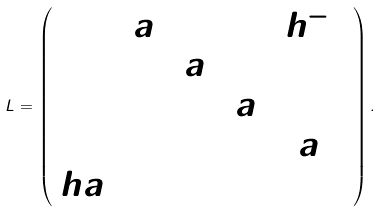<formula> <loc_0><loc_0><loc_500><loc_500>L = \left ( \begin{array} { c c c c c } 0 & a _ { 1 } & 0 & 0 & h ^ { - 1 } \\ 1 & 0 & a _ { 2 } & 0 & 0 \\ 0 & 1 & 0 & a _ { 3 } & 0 \\ 0 & 0 & 1 & 0 & a _ { 4 } \\ h a _ { 5 } & 0 & 0 & 1 & 0 \end{array} \right ) .</formula> 